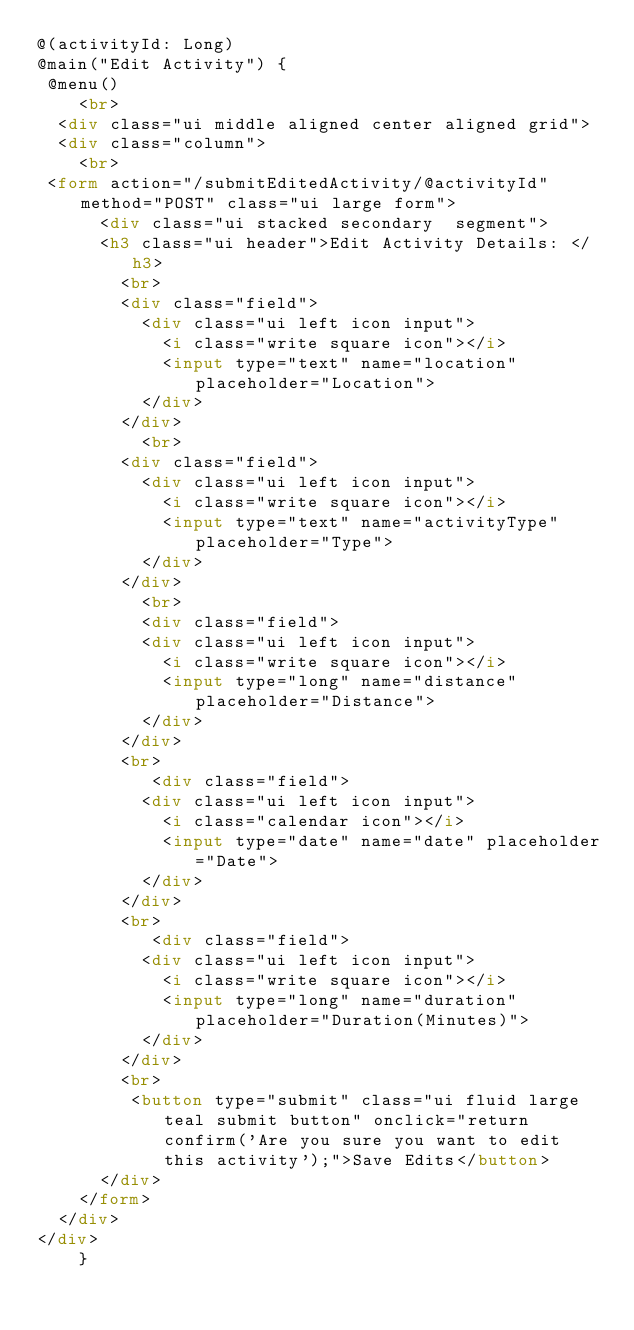Convert code to text. <code><loc_0><loc_0><loc_500><loc_500><_HTML_>@(activityId: Long)
@main("Edit Activity") { 
 @menu()    
    <br>
  <div class="ui middle aligned center aligned grid">
  <div class="column">
    <br>
 <form action="/submitEditedActivity/@activityId" method="POST" class="ui large form">
      <div class="ui stacked secondary  segment">
      <h3 class="ui header">Edit Activity Details: </h3>
        <br>
        <div class="field">
          <div class="ui left icon input">
            <i class="write square icon"></i>
            <input type="text" name="location" placeholder="Location">
          </div>
        </div>
          <br>
        <div class="field">
          <div class="ui left icon input">
            <i class="write square icon"></i>
            <input type="text" name="activityType" placeholder="Type">
          </div>
        </div>
          <br>
          <div class="field">
          <div class="ui left icon input">
            <i class="write square icon"></i>
            <input type="long" name="distance" placeholder="Distance">
          </div>
        </div>
        <br>
           <div class="field">
          <div class="ui left icon input">
            <i class="calendar icon"></i>
            <input type="date" name="date" placeholder="Date">
          </div>
        </div>
        <br>
           <div class="field">
          <div class="ui left icon input">
            <i class="write square icon"></i>
            <input type="long" name="duration" placeholder="Duration(Minutes)">
          </div>
        </div>
        <br>
         <button type="submit" class="ui fluid large teal submit button" onclick="return confirm('Are you sure you want to edit this activity');">Save Edits</button>
      </div>
    </form> 
  </div>
</div>  
    }</code> 